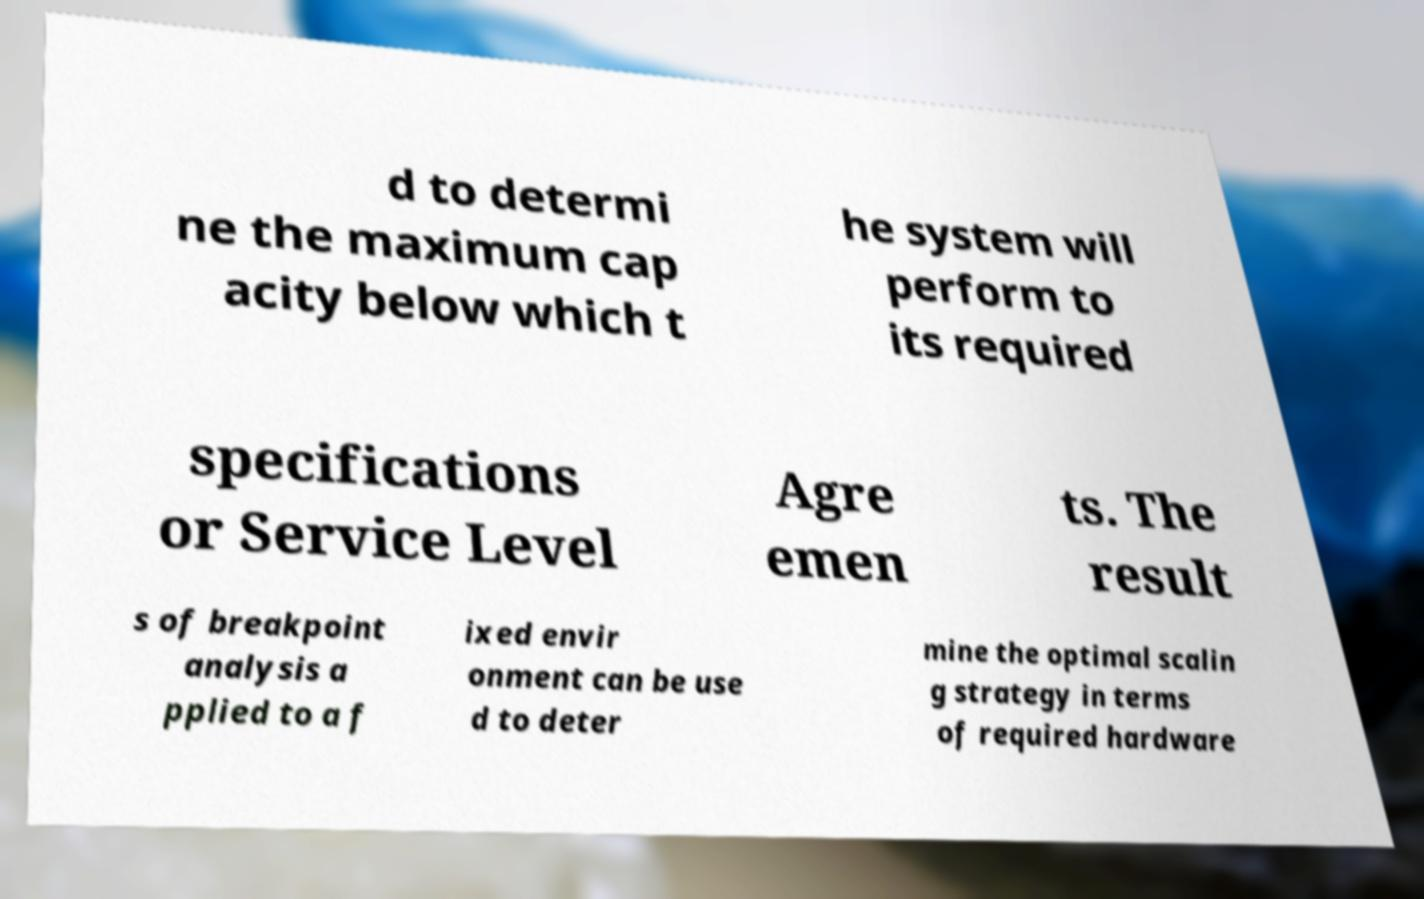There's text embedded in this image that I need extracted. Can you transcribe it verbatim? d to determi ne the maximum cap acity below which t he system will perform to its required specifications or Service Level Agre emen ts. The result s of breakpoint analysis a pplied to a f ixed envir onment can be use d to deter mine the optimal scalin g strategy in terms of required hardware 